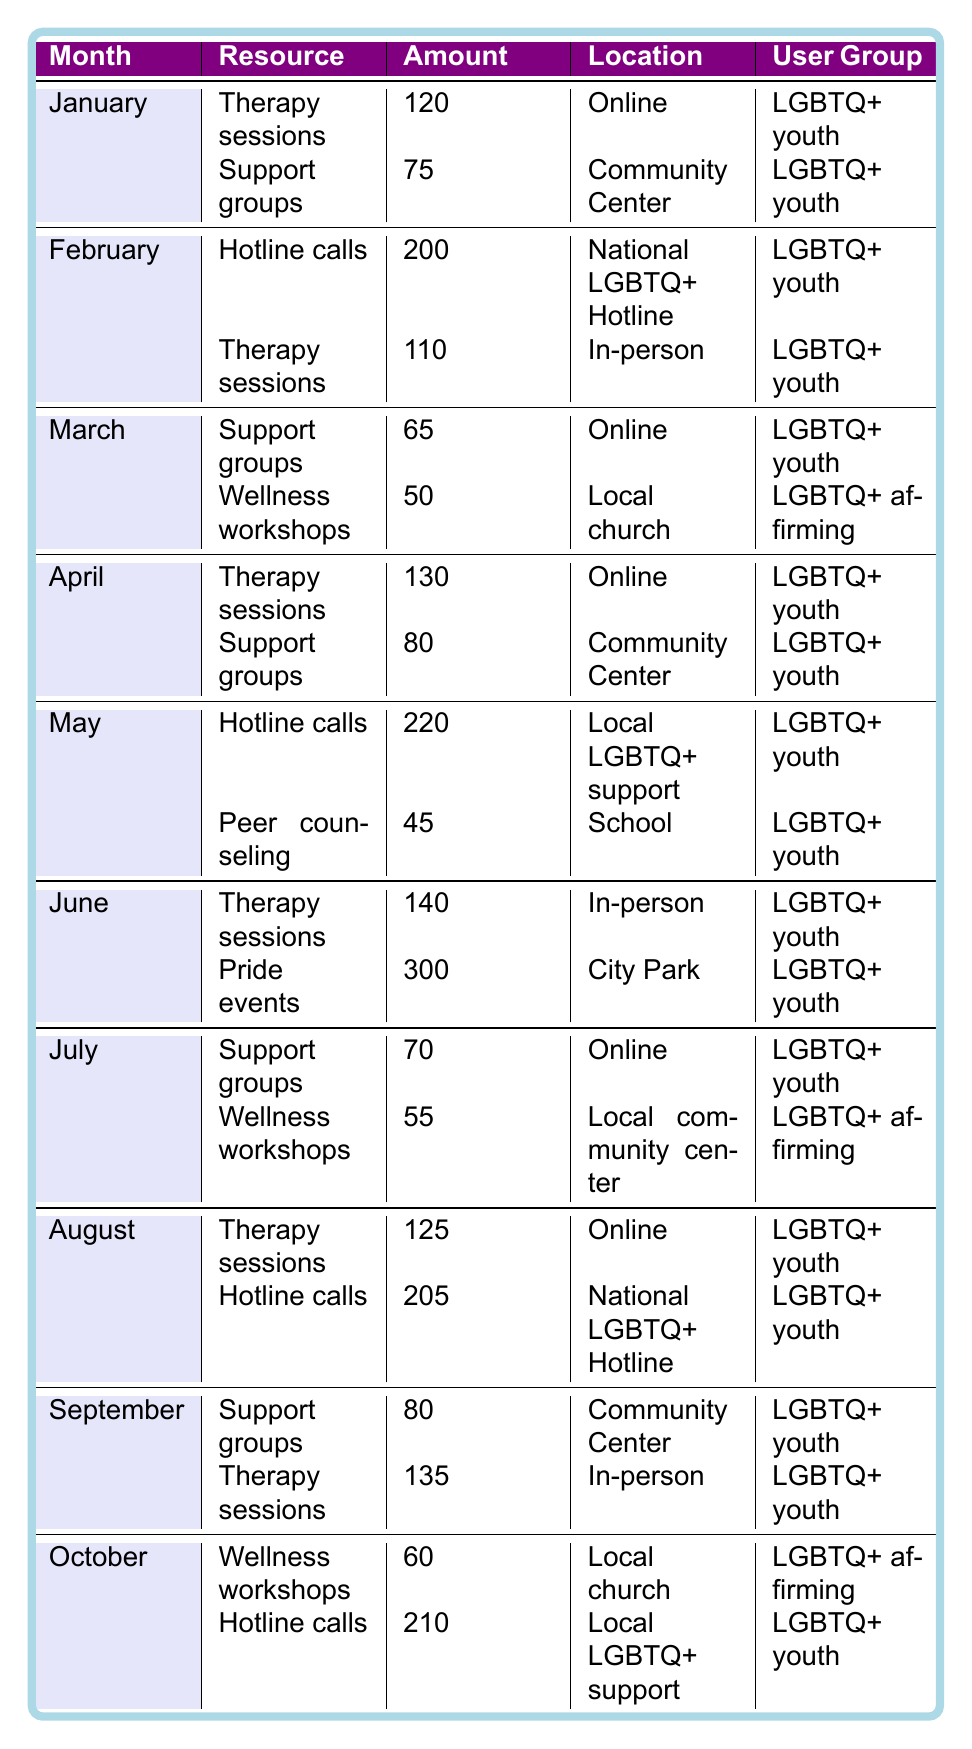What is the total number of therapy sessions used by LGBTQ+ youth in June? According to the table, in June, the amount of therapy sessions is 140. Therefore, the total number of therapy sessions used in June is 140.
Answer: 140 Which month had the highest hotline call usage by LGBTQ+ youth? The highest number of hotline calls was recorded in May with 220 calls.
Answer: May How many support groups were used by LGBTQ+ youth in January and February combined? January saw 75 support group participants, and February has 0 (not a listed resource for support groups), so the total is 75 + 0 = 75.
Answer: 75 Did August have more hotline calls or therapy sessions for LGBTQ+ youth? In August, there were 205 hotline calls and 125 therapy sessions. Since 205 is greater than 125, August had more hotline calls.
Answer: More hotline calls What is the average number of therapy sessions per month for LGBTQ+ youth from January to October? Adding up all the therapy sessions from the months (120 + 110 + 130 + 140 + 125 + 135) gives 760. Dividing by the number of months (6 months with therapy sessions) results in 760 / 6 = 126.67, which is rounded to 127 for simplicity.
Answer: 127 Which month had the least support group attendance among LGBTQ+ youth? March had the least attendance with 65 participants in support groups.
Answer: March Calculate the total amount of hotline calls from May to October for LGBTQ+ youth. Adding hotline calls from May (220), August (205), and October (210) results in 220 + 205 + 210 = 635.
Answer: 635 In which month did the most LGBTQ+ youth participate in Pride events? June had the most participation in Pride events with 300 attendees.
Answer: June How did the number of support group attendees in April compare to those in July? In April, there were 80 support group attendees, while in July, there were 70. Therefore, April had more attendees than July.
Answer: April had more attendees What percentage of the total resources used in May were hotline calls? The total resources in May include hotline calls (220) and peer counseling (45), which sums up to 220 + 45 = 265. The percentage of hotline calls is \( \frac{220}{265} \times 100 \approx 83.02\% \).
Answer: 83.02% 